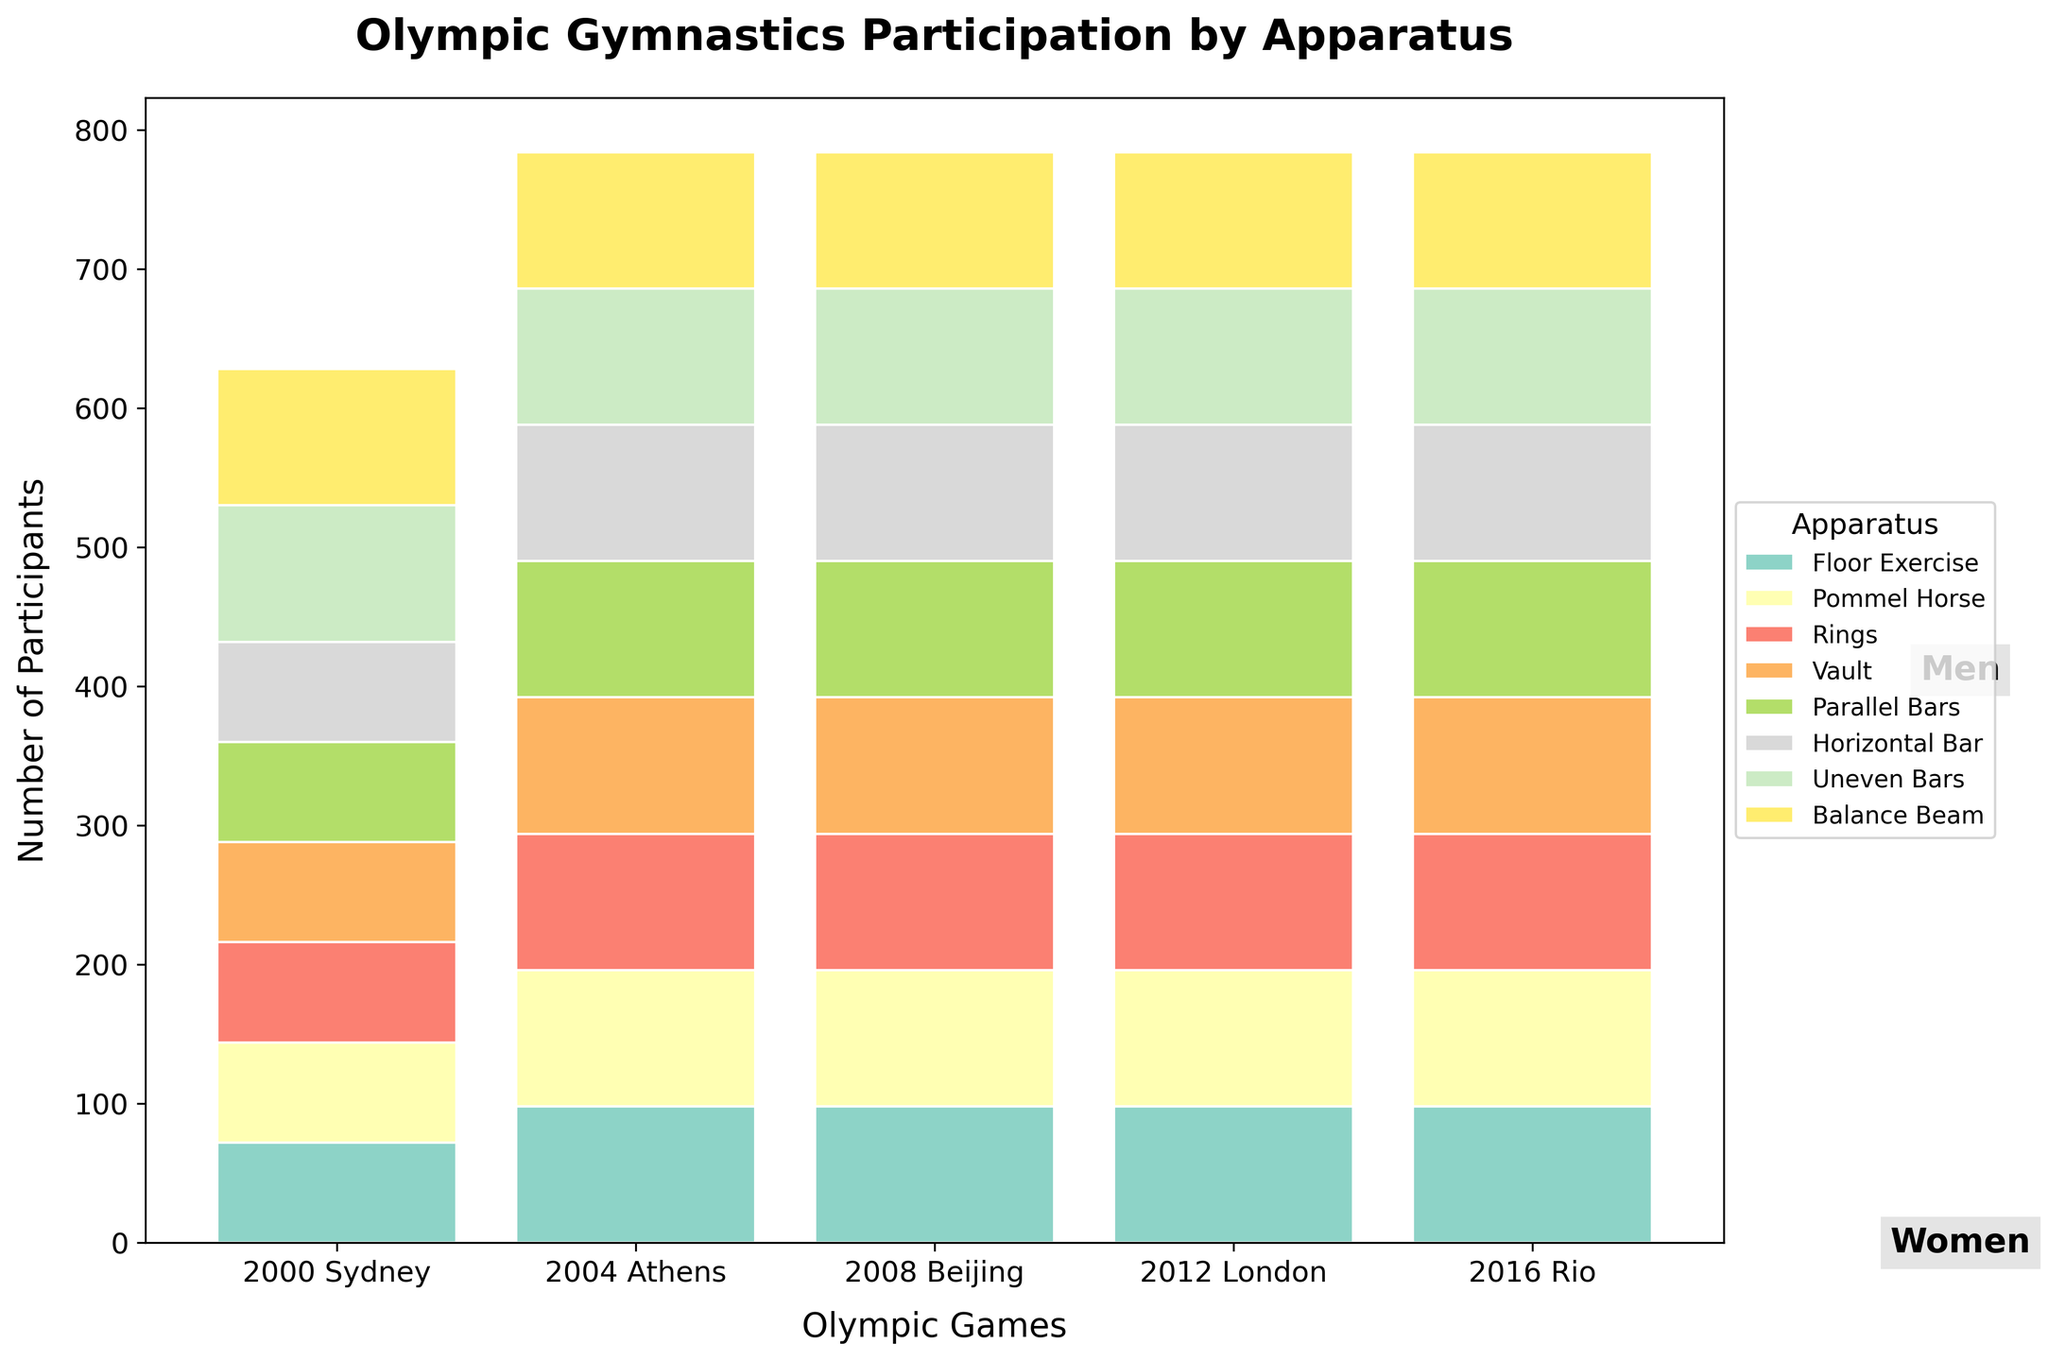How many different apparatuses are displayed in the figure? Observe the number of different colored bars in the legend of the plot, which represent different apparatuses. Count each uniquely colored bar label.
Answer: 10 What is the total number of male participants in the 2016 Rio Olympics? Sum the values for the male apparatuses in the 2016 Rio column: 98 (Floor Exercise) + 98 (Pommel Horse) + 98 (Rings) + 98 (Vault) + 98 (Parallel Bars) + 98 (Horizontal Bar).
Answer: 588 Which gender has more participants in the Vault apparatus in the 2000 Sydney Olympics? Compare the values for Male Vault and Female Vault in the 2000 Sydney column. Men: 72, Women: 98.
Answer: Women Has the number of participants for the Men's Floor Exercise changed from 2000 to 2016? Compare the participants numbers for Men's Floor Exercise from 2000 (72) to 2016 (98).
Answer: Yes What is the minimum number of participants for any apparatus in 2000 Sydney for any gender? Look at the 2000 Sydney column and find the smallest value among all apparatuses.
Answer: 72 How many more female participants were there in Floor Exercise than male participants in the same apparatus during the 2000 Sydney Olympics? Subtract the number of male participants in Floor Exercise (72) from the number of female participants in Floor Exercise (98) in 2000 Sydney.
Answer: 26 How many apparatuses have exactly 98 participants across all years? Check each apparatus's values from 2000 to 2016. Count those that have 98 participants consistently in every year column.
Answer: 3 Which apparatus saw an increase in male participants from 2000 to 2004? Compare the data for each male apparatus between 2000 and 2004. Each apparatus (e.g., Floor Exercise: 72 to 98) showed an increase.
Answer: All male apparatuses Is 2012 London the year with the highest total male participation? Calculate the total male participation for each year and compare. For example, 2012 London: 98+98+98+98+98+98 = 588. Repeat for other years.
Answer: No Which apparatus had the same participation numbers for both men and women in all years? Identify the apparatus where participant numbers were the same for both genders across all columns: Vault for Women (98) and Vault for Men after 2000 (98).
Answer: Vault 